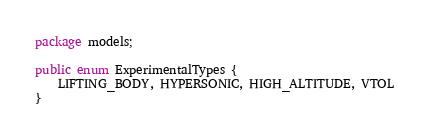Convert code to text. <code><loc_0><loc_0><loc_500><loc_500><_Java_>package models;

public enum ExperimentalTypes {
    LIFTING_BODY, HYPERSONIC, HIGH_ALTITUDE, VTOL
}
</code> 